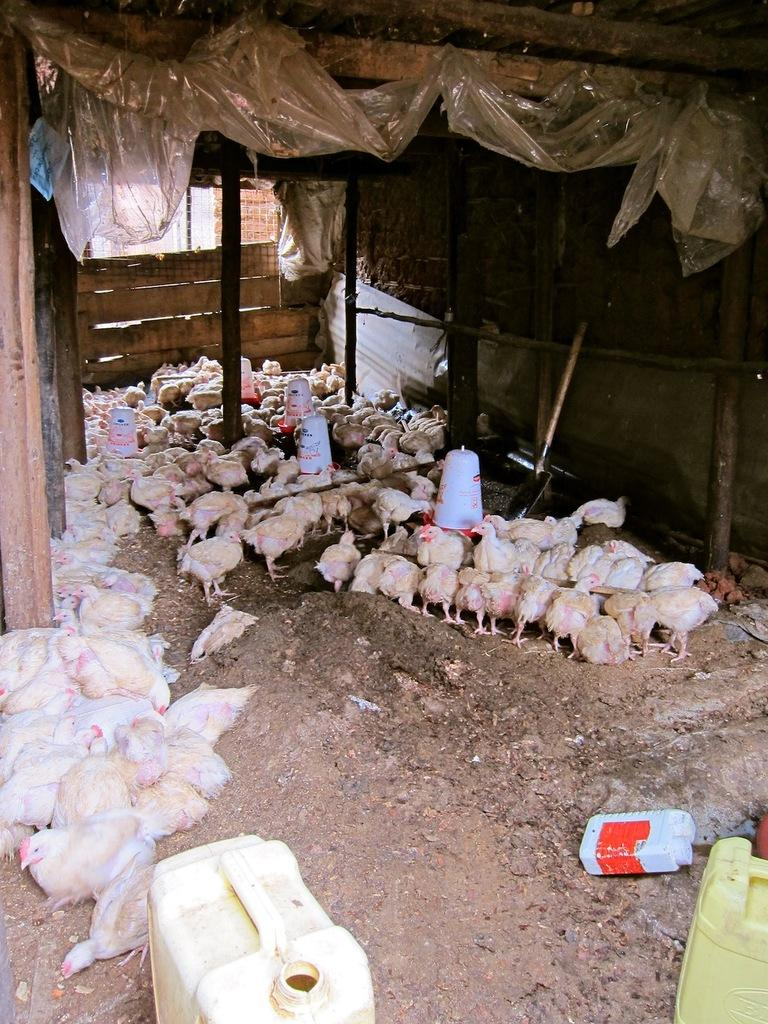What type of animals are in the image? There are hens in the image. What objects are on the ground in the image? There are water cans on the ground. What can be seen in the background of the image? There is a wall, poles, wooden planks, a sheet, and some unspecified objects in the background of the image. What type of flight is depicted in the image? There is no flight depicted in the image; it features hens and various objects in a setting. 